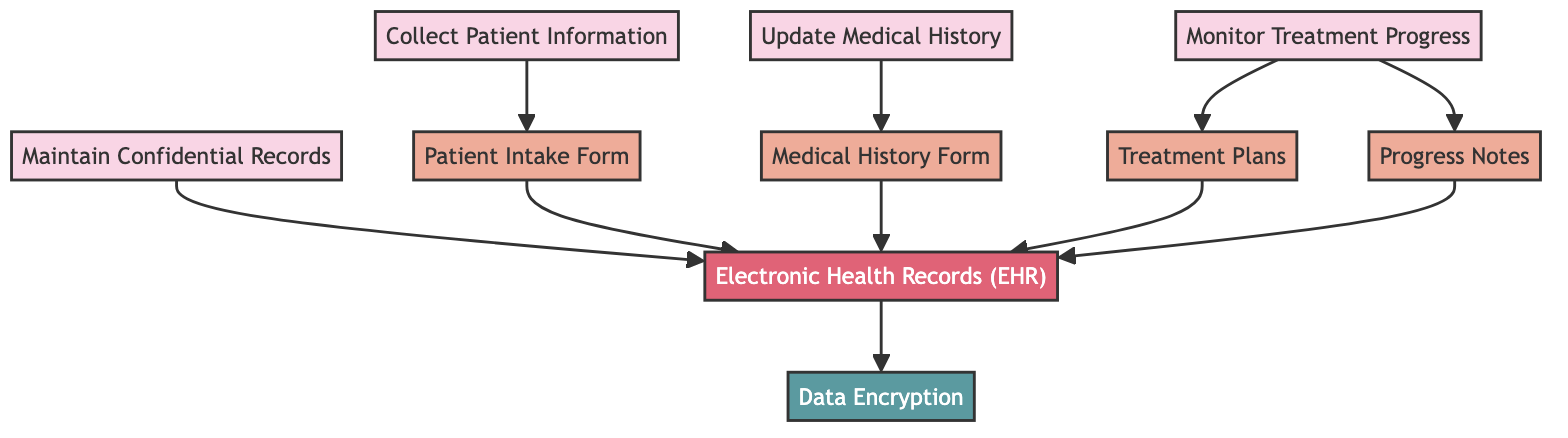What is the starting point of the patient records management process? The diagram shows "Collect Patient Information" as the first node in the workflow, indicating it's the starting point of the process.
Answer: Collect Patient Information How many nodes are there in the diagram? By counting each element in the nodes section of the data, there are ten distinct nodes representing different steps and documents related to patient records management.
Answer: 10 Which document is associated with updating medical history? The "Update Medical History" node directly links to the "Medical History Form," indicating that this document is associated with updating a patient's medical history.
Answer: Medical History Form What does the "Maintain Confidential Records" node connect to? The "Maintain Confidential Records" node has a direct connection to the "Electronic Health Records" node, showing that confidentiality maintenance leads to record storage.
Answer: Electronic Health Records Which node is related to both treatment plans and progress notes? The "Monitor Treatment Progress" node connects to both "Treatment Plans" and "Progress Notes," indicating it involves monitoring both aspects of the treatment process.
Answer: Treatment Plans and Progress Notes What is the relationship between electronic health records and data encryption? The "Electronic Health Records" node is directly linked to the "Data Encryption" node, indicating that data encryption is a necessary measure for securing electronic health records.
Answer: Data Encryption How many edges are there that lead to electronic health records? There are four direct nodes connecting to "Electronic Health Records": "Patient Intake Form," "Medical History Form," "Treatment Plans," and "Progress Notes," making a total of four edges leading to it.
Answer: 4 Which step comes after collecting patient information? The diagram shows that after "Collect Patient Information," the next step is to fill out the "Patient Intake Form," indicating the sequential flow of the process.
Answer: Patient Intake Form What is the last step in the workflow related to patient record management? The final flow indicates that "Data Encryption" is the endpoint of the workflow, as it is linked only from the "Electronic Health Records" node, signifying secured record management.
Answer: Data Encryption 